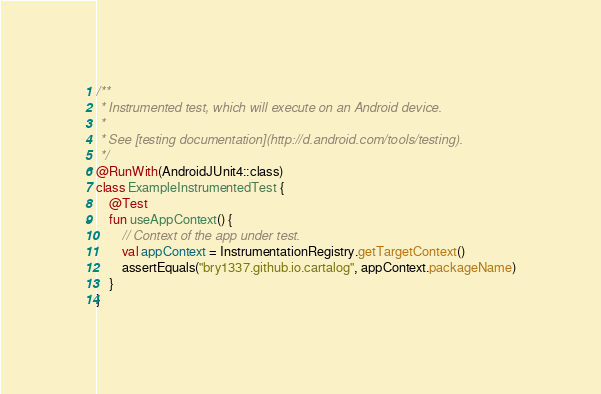Convert code to text. <code><loc_0><loc_0><loc_500><loc_500><_Kotlin_>/**
 * Instrumented test, which will execute on an Android device.
 *
 * See [testing documentation](http://d.android.com/tools/testing).
 */
@RunWith(AndroidJUnit4::class)
class ExampleInstrumentedTest {
    @Test
    fun useAppContext() {
        // Context of the app under test.
        val appContext = InstrumentationRegistry.getTargetContext()
        assertEquals("bry1337.github.io.cartalog", appContext.packageName)
    }
}
</code> 